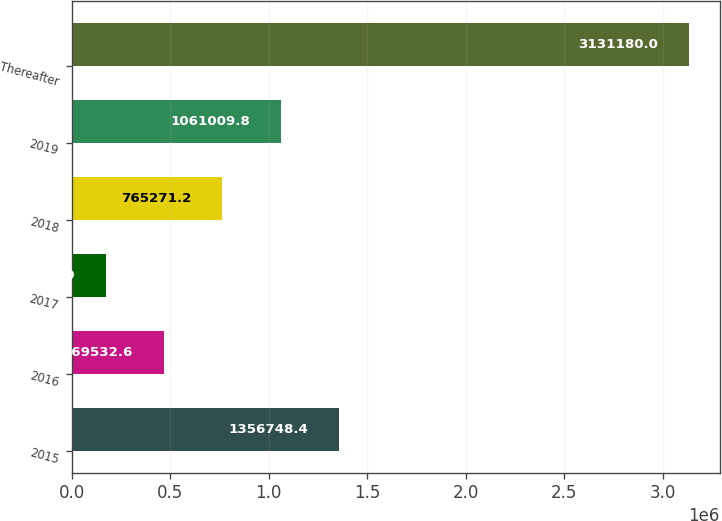Convert chart. <chart><loc_0><loc_0><loc_500><loc_500><bar_chart><fcel>2015<fcel>2016<fcel>2017<fcel>2018<fcel>2019<fcel>Thereafter<nl><fcel>1.35675e+06<fcel>469533<fcel>173794<fcel>765271<fcel>1.06101e+06<fcel>3.13118e+06<nl></chart> 